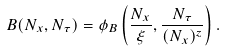Convert formula to latex. <formula><loc_0><loc_0><loc_500><loc_500>B ( N _ { x } , N _ { \tau } ) = \phi _ { B } \left ( \frac { N _ { x } } { \xi } , \frac { N _ { \tau } } { ( N _ { x } ) ^ { z } } \right ) .</formula> 